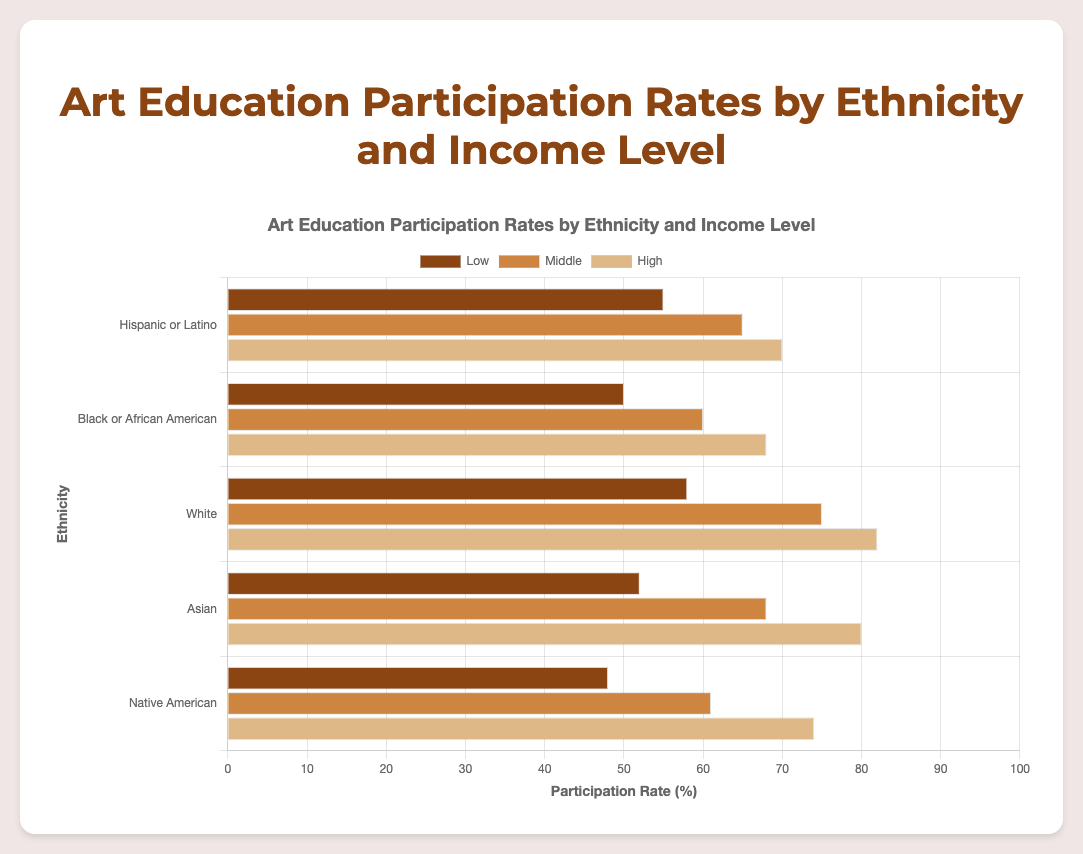Which ethnicity group has the highest participation rate in art education programs? The ethnicity group with the highest participation rate can be identified by looking at the length of the bars. The longest bar in the figure is for "White" ethnicity and "High" income level with a participation rate of 82%.
Answer: White Which income level shows the highest overall participation rate for Hispanic or Latino students? To find this, look at all the bars grouped under "Hispanic or Latino" and compare their lengths. The longest bar among these represents the "High" income level with a participation rate of 70%.
Answer: High What is the difference in participation rates between "White" students with low income and "Asian" students with high income? Find the bars representing "White" students with low income and "Asian" students with high income. The participation rates are 58% and 80%, respectively. Calculate the difference: 80% - 58% = 22%.
Answer: 22% Which income level for Native American students has a higher participation rate than the corresponding rate for Black or African American students? Compare the bars for each income level for Native American and Black or African American students. For "High" income level, Native American students show a 74% rate, which is higher than 68% for Black or African American students.
Answer: High What is the average participation rate for Asian students across all income levels? Sum the participation rates for Asian students (52%, 68%, 80%) and divide by 3. The calculation is (52 + 68 + 80) / 3 = 200 / 3 = approximately 66.67%.
Answer: 66.67% Does the participation rate for Black or African American students ever exceed 70% for any income level? Check the bars for Black or African American students; the highest rate is 68% for high income, which does not exceed 70%.
Answer: No Compare the participation rates of middle-income students across all ethnicities. Which ethnicity has the lowest rate? Inspect the participation rates for middle-income students across all ethnicities: Hispanic or Latino (65%), Black or African American (60%), White (75%), Asian (68%), and Native American (61%). The lowest rate is for Black or African American students at 60%.
Answer: Black or African American Which income level shows the least variation in participation rates across ethnicities? Calculate the range (difference between the highest and lowest rates) for each income level: 
- Low: Hispanic or Latino (55%) to Native American (48%), range = 7%.
- Middle: White (75%) to Black or African American (60%), range = 15%
- High: White (82%) to Black or African American (68%), range = 14%. 
The low-income level shows the least variation at 7%.
Answer: Low 